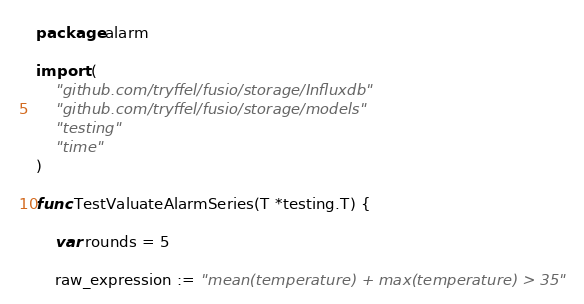<code> <loc_0><loc_0><loc_500><loc_500><_Go_>package alarm

import (
	"github.com/tryffel/fusio/storage/Influxdb"
	"github.com/tryffel/fusio/storage/models"
	"testing"
	"time"
)

func TestValuateAlarmSeries(T *testing.T) {

	var rounds = 5

	raw_expression := "mean(temperature) + max(temperature) > 35"</code> 